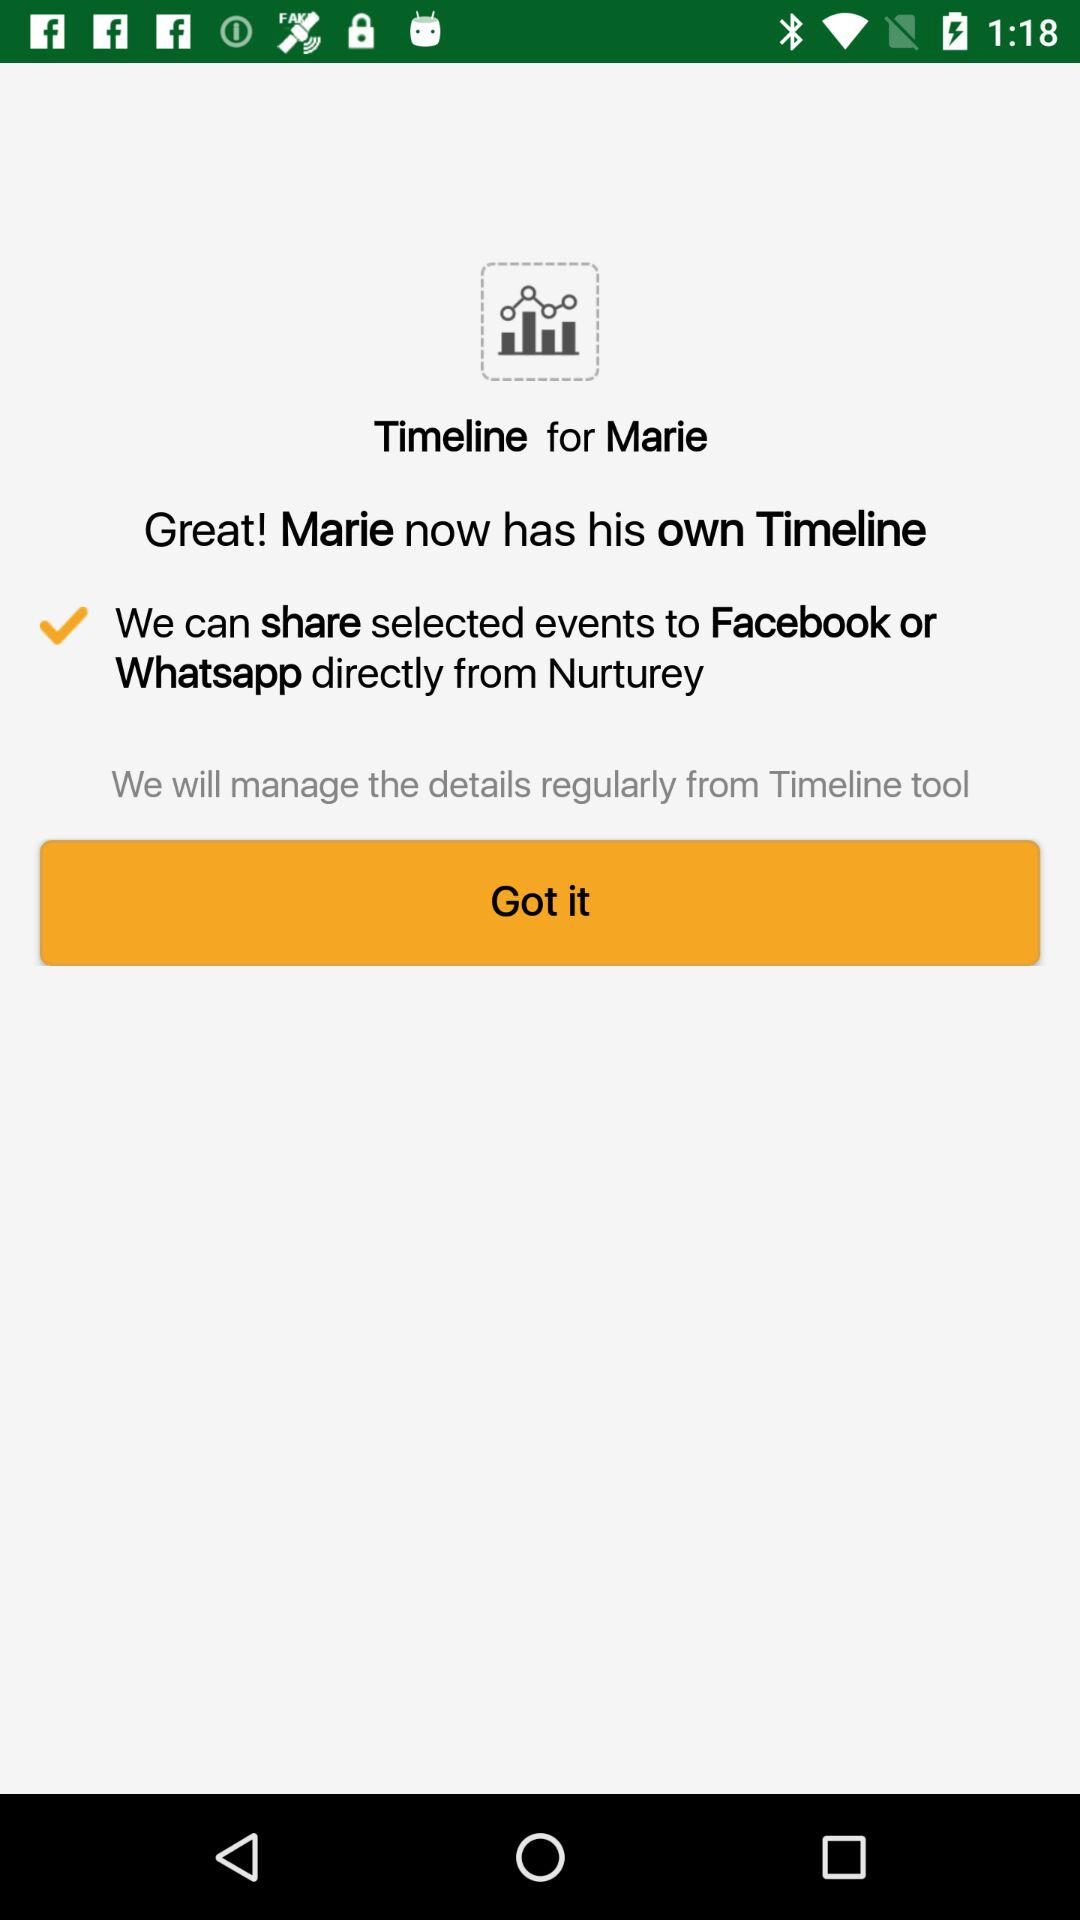Through what application can we share the selected events? We can share the selected events through "Facebook" and "Whatsapp". 